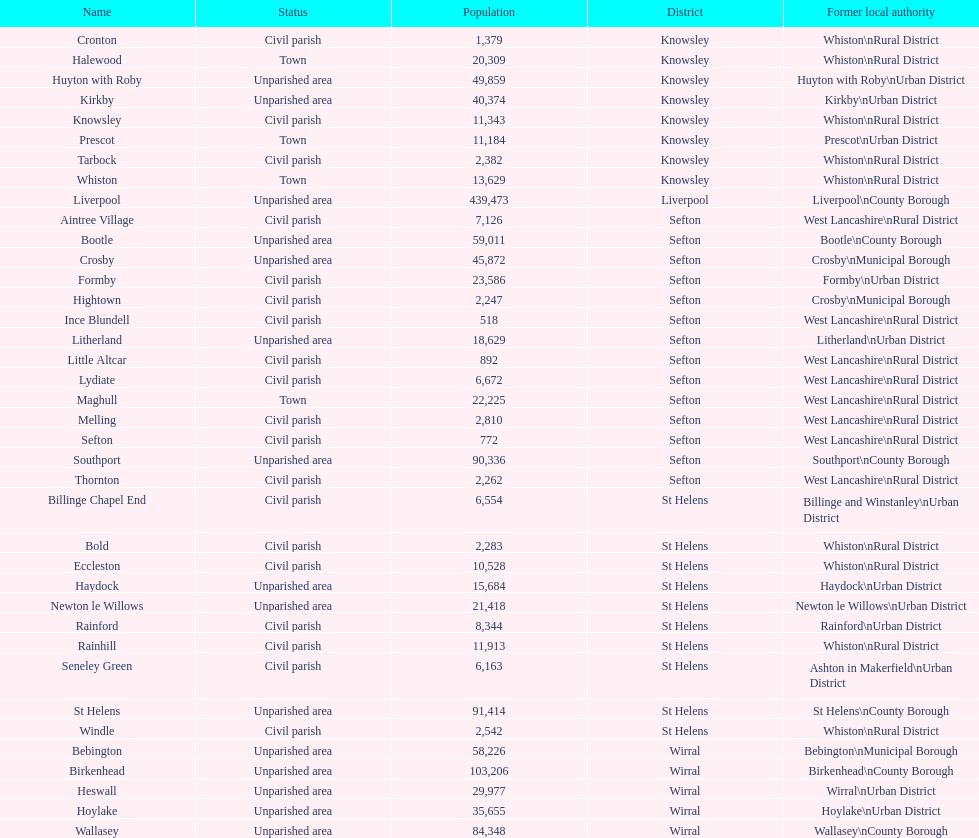Where is the lowest number of inhabitants located? Ince Blundell. 